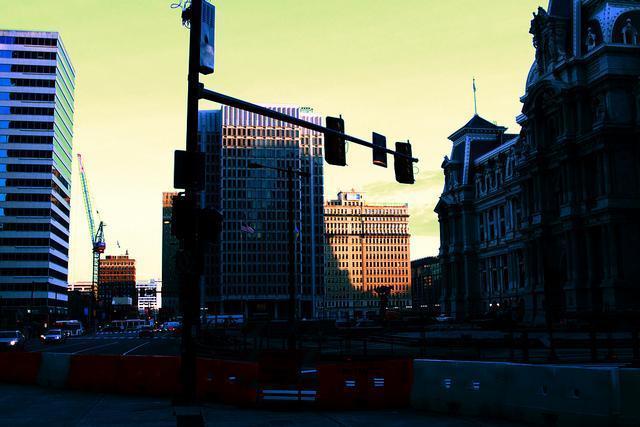How many people are sitting at the table?
Give a very brief answer. 0. 